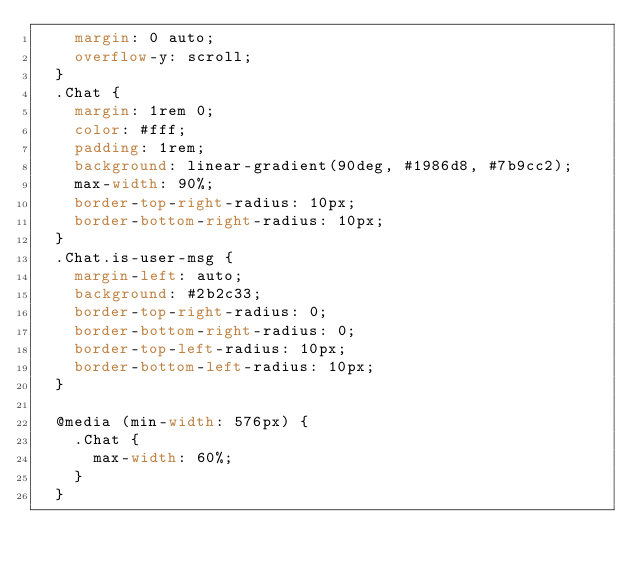Convert code to text. <code><loc_0><loc_0><loc_500><loc_500><_CSS_>    margin: 0 auto;
    overflow-y: scroll;
  }
  .Chat {
    margin: 1rem 0;
    color: #fff;
    padding: 1rem;
    background: linear-gradient(90deg, #1986d8, #7b9cc2);
    max-width: 90%;
    border-top-right-radius: 10px;
    border-bottom-right-radius: 10px;
  }
  .Chat.is-user-msg {
    margin-left: auto;
    background: #2b2c33;
    border-top-right-radius: 0;
    border-bottom-right-radius: 0;
    border-top-left-radius: 10px;
    border-bottom-left-radius: 10px;
  }
  
  @media (min-width: 576px) {
    .Chat {
      max-width: 60%;
    }
  }</code> 